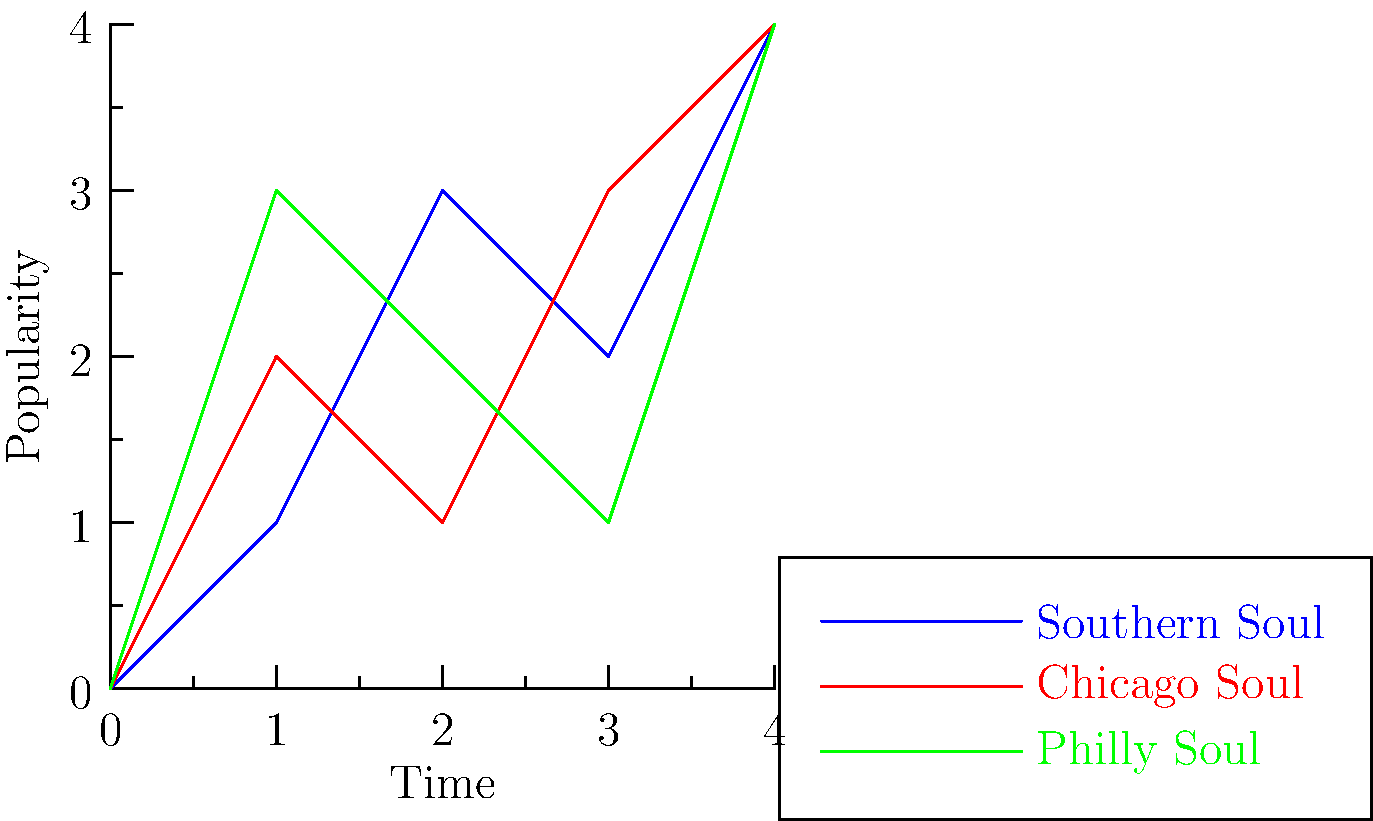In the topological data analysis of soul music subgenres, which subgenre shows the most distinct pattern of popularity over time, suggesting a unique cultural impact? To determine which subgenre shows the most distinct pattern, we need to analyze the graph:

1. Southern Soul (blue line):
   - Starts at 0, rises steadily to 3, dips slightly, then rises to 4.
   - Shows a generally increasing trend with one minor fluctuation.

2. Chicago Soul (red line):
   - Starts at 0, rises sharply to 2, dips to 1, rises to 3, then to 4.
   - Exhibits more variability with clear ups and downs.

3. Philly Soul (green line):
   - Starts at 0, rises sharply to 3, then steadily decreases to 1 before rising to 4.
   - Demonstrates a unique "peak-valley-peak" pattern.

Comparing these patterns:
- Southern Soul is the most consistent but least distinct.
- Chicago Soul shows variability but follows a somewhat similar pattern to Southern Soul.
- Philly Soul stands out with its clear peak early on, followed by a decline and then a rise.

The Philly Soul subgenre exhibits the most distinct pattern, suggesting a unique cultural impact characterized by an initial surge in popularity, followed by a decline, and then a resurgence.
Answer: Philly Soul 